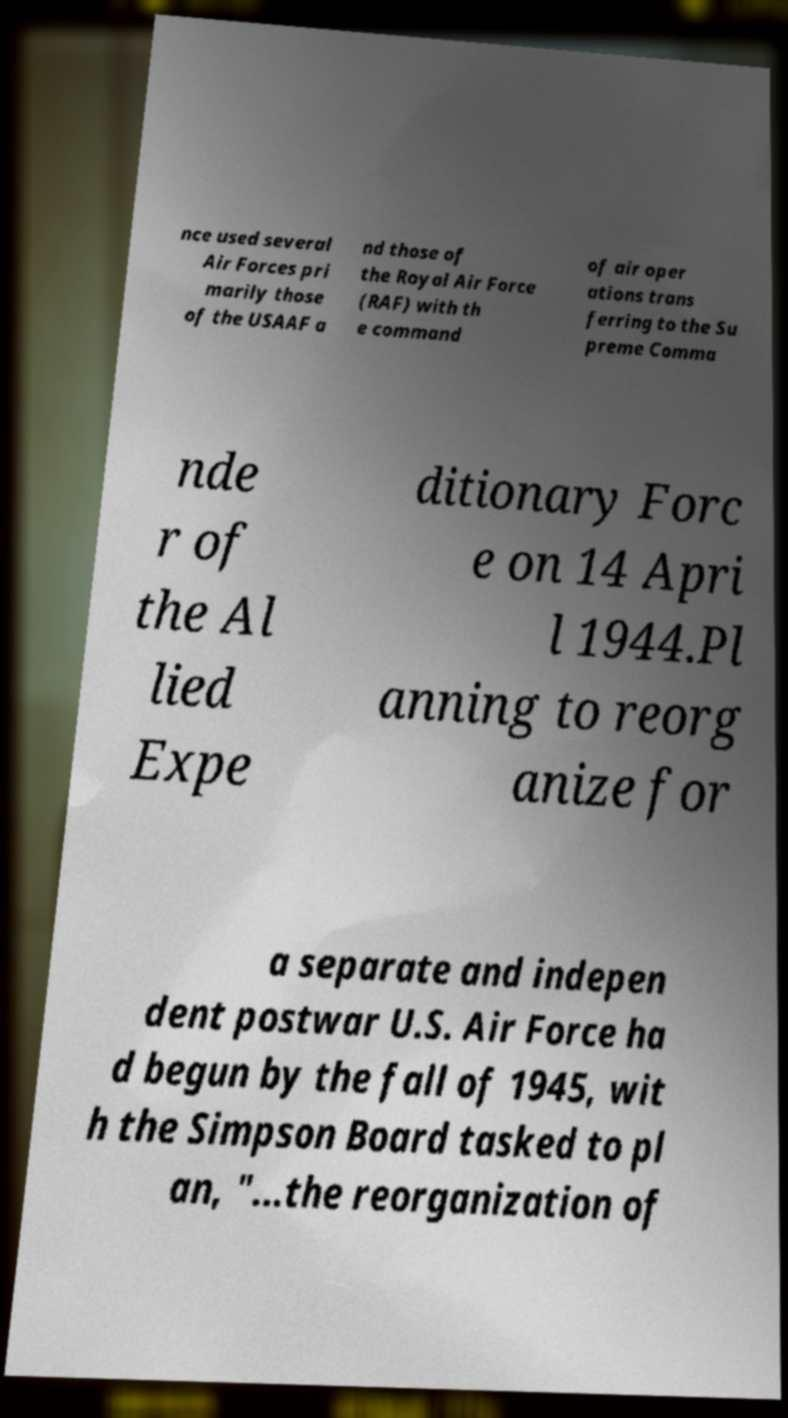Can you read and provide the text displayed in the image?This photo seems to have some interesting text. Can you extract and type it out for me? nce used several Air Forces pri marily those of the USAAF a nd those of the Royal Air Force (RAF) with th e command of air oper ations trans ferring to the Su preme Comma nde r of the Al lied Expe ditionary Forc e on 14 Apri l 1944.Pl anning to reorg anize for a separate and indepen dent postwar U.S. Air Force ha d begun by the fall of 1945, wit h the Simpson Board tasked to pl an, "...the reorganization of 